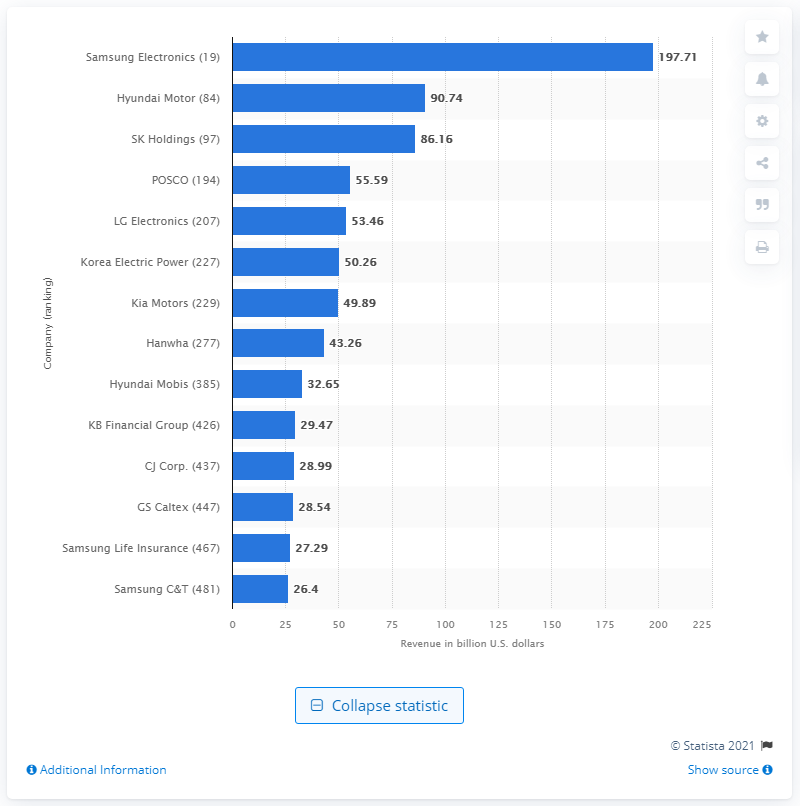Point out several critical features in this image. In 2020, the revenue of Hyundai Motors in the United States was 90.74 million. 